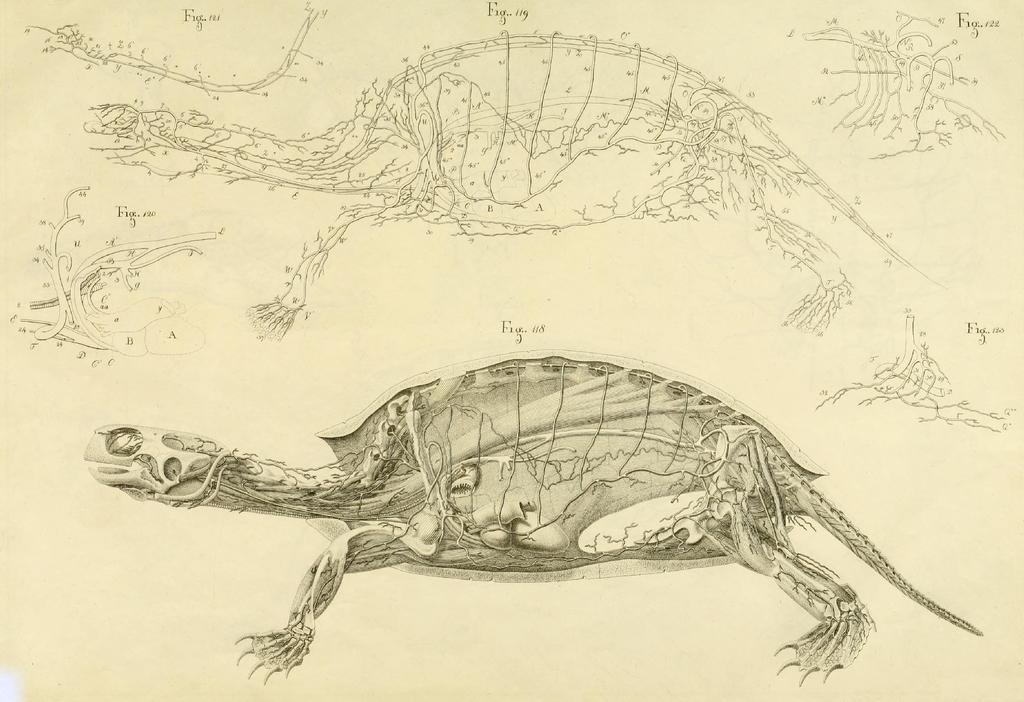What is depicted in the drawing in the image? There is a drawing of a turtle in the image. Are there any additional elements in the image besides the drawing? Yes, there are labels in the image. How long does it take for the river to freeze in the image? There is no river present in the image, so it is not possible to determine how long it would take for it to freeze. 